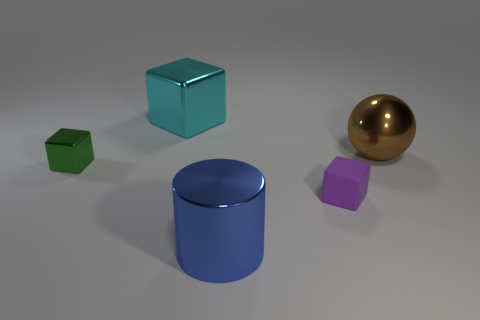Add 3 large cyan rubber things. How many objects exist? 8 Subtract all cylinders. How many objects are left? 4 Add 1 large cyan metal things. How many large cyan metal things exist? 2 Subtract 0 yellow cylinders. How many objects are left? 5 Subtract all large purple metallic things. Subtract all large blue cylinders. How many objects are left? 4 Add 5 large brown spheres. How many large brown spheres are left? 6 